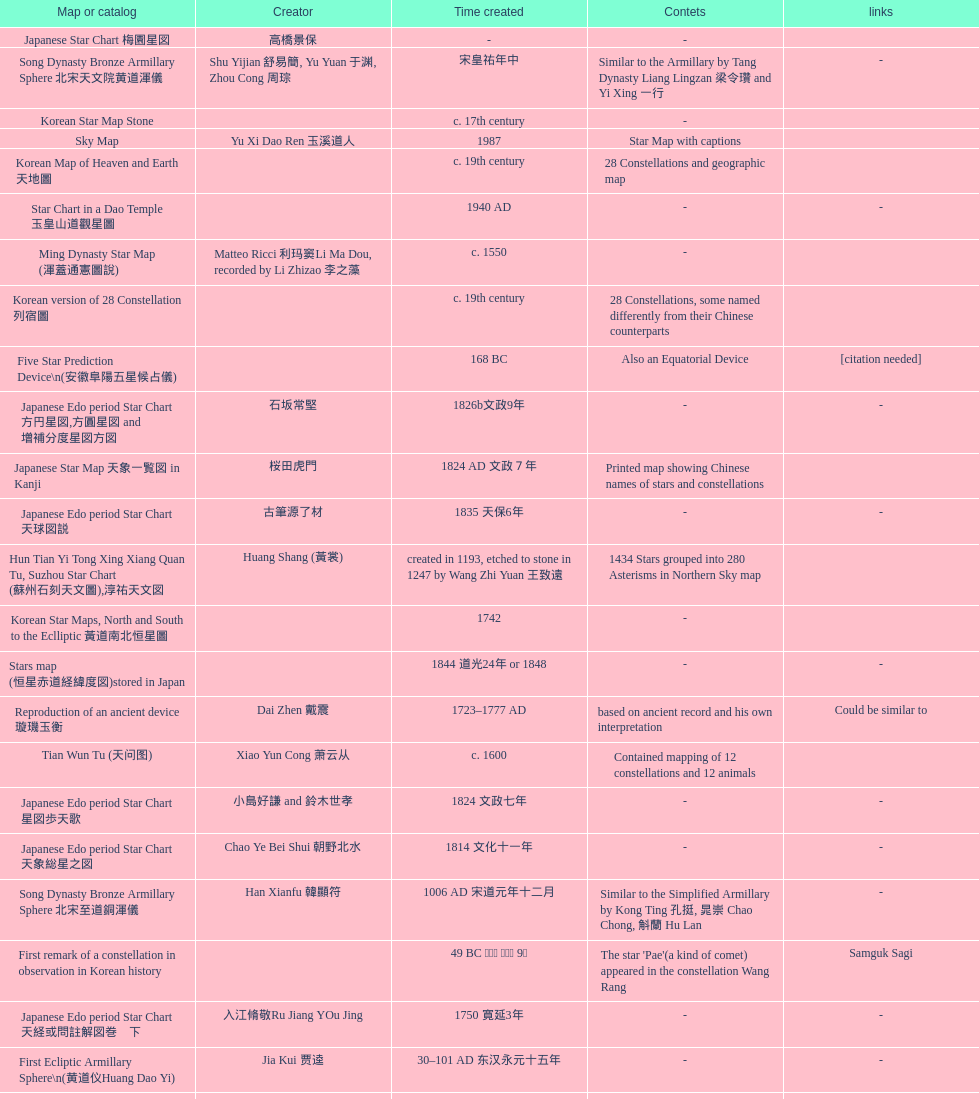What is the name of the oldest map/catalog? M45. 